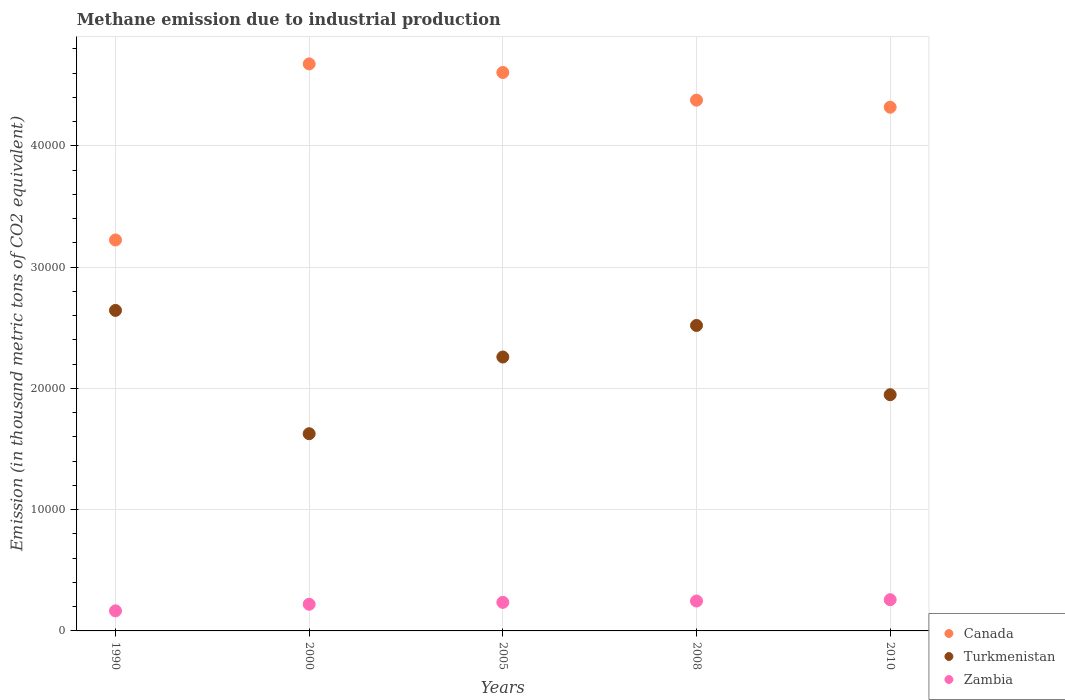Is the number of dotlines equal to the number of legend labels?
Offer a terse response. Yes. What is the amount of methane emitted in Turkmenistan in 2010?
Keep it short and to the point. 1.95e+04. Across all years, what is the maximum amount of methane emitted in Canada?
Your answer should be very brief. 4.68e+04. Across all years, what is the minimum amount of methane emitted in Zambia?
Provide a succinct answer. 1655.8. In which year was the amount of methane emitted in Turkmenistan minimum?
Offer a very short reply. 2000. What is the total amount of methane emitted in Canada in the graph?
Provide a short and direct response. 2.12e+05. What is the difference between the amount of methane emitted in Zambia in 2005 and that in 2010?
Offer a terse response. -219.7. What is the difference between the amount of methane emitted in Canada in 2005 and the amount of methane emitted in Turkmenistan in 2000?
Keep it short and to the point. 2.98e+04. What is the average amount of methane emitted in Canada per year?
Your answer should be compact. 4.24e+04. In the year 2005, what is the difference between the amount of methane emitted in Zambia and amount of methane emitted in Canada?
Offer a very short reply. -4.37e+04. In how many years, is the amount of methane emitted in Turkmenistan greater than 24000 thousand metric tons?
Provide a succinct answer. 2. What is the ratio of the amount of methane emitted in Turkmenistan in 2000 to that in 2010?
Ensure brevity in your answer.  0.83. What is the difference between the highest and the second highest amount of methane emitted in Turkmenistan?
Provide a succinct answer. 1240.2. What is the difference between the highest and the lowest amount of methane emitted in Canada?
Your answer should be compact. 1.45e+04. In how many years, is the amount of methane emitted in Turkmenistan greater than the average amount of methane emitted in Turkmenistan taken over all years?
Ensure brevity in your answer.  3. Is the sum of the amount of methane emitted in Zambia in 1990 and 2008 greater than the maximum amount of methane emitted in Canada across all years?
Ensure brevity in your answer.  No. Is it the case that in every year, the sum of the amount of methane emitted in Zambia and amount of methane emitted in Canada  is greater than the amount of methane emitted in Turkmenistan?
Your answer should be very brief. Yes. Does the amount of methane emitted in Canada monotonically increase over the years?
Make the answer very short. No. How many dotlines are there?
Provide a short and direct response. 3. What is the difference between two consecutive major ticks on the Y-axis?
Ensure brevity in your answer.  10000. Does the graph contain any zero values?
Give a very brief answer. No. Does the graph contain grids?
Provide a succinct answer. Yes. Where does the legend appear in the graph?
Your answer should be very brief. Bottom right. How many legend labels are there?
Your response must be concise. 3. What is the title of the graph?
Offer a terse response. Methane emission due to industrial production. What is the label or title of the X-axis?
Provide a short and direct response. Years. What is the label or title of the Y-axis?
Offer a terse response. Emission (in thousand metric tons of CO2 equivalent). What is the Emission (in thousand metric tons of CO2 equivalent) of Canada in 1990?
Make the answer very short. 3.22e+04. What is the Emission (in thousand metric tons of CO2 equivalent) in Turkmenistan in 1990?
Keep it short and to the point. 2.64e+04. What is the Emission (in thousand metric tons of CO2 equivalent) of Zambia in 1990?
Ensure brevity in your answer.  1655.8. What is the Emission (in thousand metric tons of CO2 equivalent) of Canada in 2000?
Give a very brief answer. 4.68e+04. What is the Emission (in thousand metric tons of CO2 equivalent) in Turkmenistan in 2000?
Ensure brevity in your answer.  1.63e+04. What is the Emission (in thousand metric tons of CO2 equivalent) in Zambia in 2000?
Give a very brief answer. 2197.5. What is the Emission (in thousand metric tons of CO2 equivalent) of Canada in 2005?
Your answer should be compact. 4.60e+04. What is the Emission (in thousand metric tons of CO2 equivalent) of Turkmenistan in 2005?
Provide a short and direct response. 2.26e+04. What is the Emission (in thousand metric tons of CO2 equivalent) of Zambia in 2005?
Offer a terse response. 2355. What is the Emission (in thousand metric tons of CO2 equivalent) of Canada in 2008?
Give a very brief answer. 4.38e+04. What is the Emission (in thousand metric tons of CO2 equivalent) in Turkmenistan in 2008?
Give a very brief answer. 2.52e+04. What is the Emission (in thousand metric tons of CO2 equivalent) in Zambia in 2008?
Your answer should be compact. 2464.9. What is the Emission (in thousand metric tons of CO2 equivalent) of Canada in 2010?
Ensure brevity in your answer.  4.32e+04. What is the Emission (in thousand metric tons of CO2 equivalent) in Turkmenistan in 2010?
Keep it short and to the point. 1.95e+04. What is the Emission (in thousand metric tons of CO2 equivalent) of Zambia in 2010?
Your response must be concise. 2574.7. Across all years, what is the maximum Emission (in thousand metric tons of CO2 equivalent) in Canada?
Ensure brevity in your answer.  4.68e+04. Across all years, what is the maximum Emission (in thousand metric tons of CO2 equivalent) in Turkmenistan?
Provide a short and direct response. 2.64e+04. Across all years, what is the maximum Emission (in thousand metric tons of CO2 equivalent) of Zambia?
Your answer should be very brief. 2574.7. Across all years, what is the minimum Emission (in thousand metric tons of CO2 equivalent) in Canada?
Ensure brevity in your answer.  3.22e+04. Across all years, what is the minimum Emission (in thousand metric tons of CO2 equivalent) of Turkmenistan?
Provide a succinct answer. 1.63e+04. Across all years, what is the minimum Emission (in thousand metric tons of CO2 equivalent) in Zambia?
Provide a succinct answer. 1655.8. What is the total Emission (in thousand metric tons of CO2 equivalent) in Canada in the graph?
Provide a short and direct response. 2.12e+05. What is the total Emission (in thousand metric tons of CO2 equivalent) of Turkmenistan in the graph?
Provide a succinct answer. 1.10e+05. What is the total Emission (in thousand metric tons of CO2 equivalent) in Zambia in the graph?
Provide a short and direct response. 1.12e+04. What is the difference between the Emission (in thousand metric tons of CO2 equivalent) in Canada in 1990 and that in 2000?
Provide a succinct answer. -1.45e+04. What is the difference between the Emission (in thousand metric tons of CO2 equivalent) in Turkmenistan in 1990 and that in 2000?
Provide a short and direct response. 1.02e+04. What is the difference between the Emission (in thousand metric tons of CO2 equivalent) in Zambia in 1990 and that in 2000?
Provide a succinct answer. -541.7. What is the difference between the Emission (in thousand metric tons of CO2 equivalent) of Canada in 1990 and that in 2005?
Provide a succinct answer. -1.38e+04. What is the difference between the Emission (in thousand metric tons of CO2 equivalent) in Turkmenistan in 1990 and that in 2005?
Your answer should be very brief. 3842.2. What is the difference between the Emission (in thousand metric tons of CO2 equivalent) of Zambia in 1990 and that in 2005?
Your answer should be very brief. -699.2. What is the difference between the Emission (in thousand metric tons of CO2 equivalent) of Canada in 1990 and that in 2008?
Keep it short and to the point. -1.15e+04. What is the difference between the Emission (in thousand metric tons of CO2 equivalent) in Turkmenistan in 1990 and that in 2008?
Offer a very short reply. 1240.2. What is the difference between the Emission (in thousand metric tons of CO2 equivalent) of Zambia in 1990 and that in 2008?
Offer a terse response. -809.1. What is the difference between the Emission (in thousand metric tons of CO2 equivalent) in Canada in 1990 and that in 2010?
Your answer should be very brief. -1.09e+04. What is the difference between the Emission (in thousand metric tons of CO2 equivalent) in Turkmenistan in 1990 and that in 2010?
Provide a succinct answer. 6950.9. What is the difference between the Emission (in thousand metric tons of CO2 equivalent) of Zambia in 1990 and that in 2010?
Your answer should be very brief. -918.9. What is the difference between the Emission (in thousand metric tons of CO2 equivalent) of Canada in 2000 and that in 2005?
Make the answer very short. 705.9. What is the difference between the Emission (in thousand metric tons of CO2 equivalent) in Turkmenistan in 2000 and that in 2005?
Your response must be concise. -6325. What is the difference between the Emission (in thousand metric tons of CO2 equivalent) of Zambia in 2000 and that in 2005?
Provide a succinct answer. -157.5. What is the difference between the Emission (in thousand metric tons of CO2 equivalent) in Canada in 2000 and that in 2008?
Your answer should be compact. 2987.1. What is the difference between the Emission (in thousand metric tons of CO2 equivalent) of Turkmenistan in 2000 and that in 2008?
Provide a short and direct response. -8927. What is the difference between the Emission (in thousand metric tons of CO2 equivalent) in Zambia in 2000 and that in 2008?
Your response must be concise. -267.4. What is the difference between the Emission (in thousand metric tons of CO2 equivalent) in Canada in 2000 and that in 2010?
Offer a terse response. 3569.2. What is the difference between the Emission (in thousand metric tons of CO2 equivalent) in Turkmenistan in 2000 and that in 2010?
Keep it short and to the point. -3216.3. What is the difference between the Emission (in thousand metric tons of CO2 equivalent) in Zambia in 2000 and that in 2010?
Provide a short and direct response. -377.2. What is the difference between the Emission (in thousand metric tons of CO2 equivalent) in Canada in 2005 and that in 2008?
Offer a terse response. 2281.2. What is the difference between the Emission (in thousand metric tons of CO2 equivalent) in Turkmenistan in 2005 and that in 2008?
Your response must be concise. -2602. What is the difference between the Emission (in thousand metric tons of CO2 equivalent) of Zambia in 2005 and that in 2008?
Offer a terse response. -109.9. What is the difference between the Emission (in thousand metric tons of CO2 equivalent) of Canada in 2005 and that in 2010?
Your answer should be compact. 2863.3. What is the difference between the Emission (in thousand metric tons of CO2 equivalent) of Turkmenistan in 2005 and that in 2010?
Offer a very short reply. 3108.7. What is the difference between the Emission (in thousand metric tons of CO2 equivalent) in Zambia in 2005 and that in 2010?
Provide a succinct answer. -219.7. What is the difference between the Emission (in thousand metric tons of CO2 equivalent) in Canada in 2008 and that in 2010?
Offer a terse response. 582.1. What is the difference between the Emission (in thousand metric tons of CO2 equivalent) of Turkmenistan in 2008 and that in 2010?
Ensure brevity in your answer.  5710.7. What is the difference between the Emission (in thousand metric tons of CO2 equivalent) in Zambia in 2008 and that in 2010?
Give a very brief answer. -109.8. What is the difference between the Emission (in thousand metric tons of CO2 equivalent) of Canada in 1990 and the Emission (in thousand metric tons of CO2 equivalent) of Turkmenistan in 2000?
Provide a succinct answer. 1.60e+04. What is the difference between the Emission (in thousand metric tons of CO2 equivalent) of Canada in 1990 and the Emission (in thousand metric tons of CO2 equivalent) of Zambia in 2000?
Provide a succinct answer. 3.00e+04. What is the difference between the Emission (in thousand metric tons of CO2 equivalent) of Turkmenistan in 1990 and the Emission (in thousand metric tons of CO2 equivalent) of Zambia in 2000?
Ensure brevity in your answer.  2.42e+04. What is the difference between the Emission (in thousand metric tons of CO2 equivalent) of Canada in 1990 and the Emission (in thousand metric tons of CO2 equivalent) of Turkmenistan in 2005?
Your answer should be compact. 9649.1. What is the difference between the Emission (in thousand metric tons of CO2 equivalent) in Canada in 1990 and the Emission (in thousand metric tons of CO2 equivalent) in Zambia in 2005?
Your answer should be compact. 2.99e+04. What is the difference between the Emission (in thousand metric tons of CO2 equivalent) in Turkmenistan in 1990 and the Emission (in thousand metric tons of CO2 equivalent) in Zambia in 2005?
Your answer should be very brief. 2.41e+04. What is the difference between the Emission (in thousand metric tons of CO2 equivalent) in Canada in 1990 and the Emission (in thousand metric tons of CO2 equivalent) in Turkmenistan in 2008?
Make the answer very short. 7047.1. What is the difference between the Emission (in thousand metric tons of CO2 equivalent) of Canada in 1990 and the Emission (in thousand metric tons of CO2 equivalent) of Zambia in 2008?
Your response must be concise. 2.98e+04. What is the difference between the Emission (in thousand metric tons of CO2 equivalent) in Turkmenistan in 1990 and the Emission (in thousand metric tons of CO2 equivalent) in Zambia in 2008?
Your answer should be very brief. 2.40e+04. What is the difference between the Emission (in thousand metric tons of CO2 equivalent) of Canada in 1990 and the Emission (in thousand metric tons of CO2 equivalent) of Turkmenistan in 2010?
Provide a succinct answer. 1.28e+04. What is the difference between the Emission (in thousand metric tons of CO2 equivalent) of Canada in 1990 and the Emission (in thousand metric tons of CO2 equivalent) of Zambia in 2010?
Offer a very short reply. 2.97e+04. What is the difference between the Emission (in thousand metric tons of CO2 equivalent) in Turkmenistan in 1990 and the Emission (in thousand metric tons of CO2 equivalent) in Zambia in 2010?
Your answer should be compact. 2.39e+04. What is the difference between the Emission (in thousand metric tons of CO2 equivalent) in Canada in 2000 and the Emission (in thousand metric tons of CO2 equivalent) in Turkmenistan in 2005?
Make the answer very short. 2.42e+04. What is the difference between the Emission (in thousand metric tons of CO2 equivalent) of Canada in 2000 and the Emission (in thousand metric tons of CO2 equivalent) of Zambia in 2005?
Keep it short and to the point. 4.44e+04. What is the difference between the Emission (in thousand metric tons of CO2 equivalent) of Turkmenistan in 2000 and the Emission (in thousand metric tons of CO2 equivalent) of Zambia in 2005?
Your answer should be compact. 1.39e+04. What is the difference between the Emission (in thousand metric tons of CO2 equivalent) of Canada in 2000 and the Emission (in thousand metric tons of CO2 equivalent) of Turkmenistan in 2008?
Offer a very short reply. 2.16e+04. What is the difference between the Emission (in thousand metric tons of CO2 equivalent) of Canada in 2000 and the Emission (in thousand metric tons of CO2 equivalent) of Zambia in 2008?
Your response must be concise. 4.43e+04. What is the difference between the Emission (in thousand metric tons of CO2 equivalent) of Turkmenistan in 2000 and the Emission (in thousand metric tons of CO2 equivalent) of Zambia in 2008?
Your answer should be very brief. 1.38e+04. What is the difference between the Emission (in thousand metric tons of CO2 equivalent) in Canada in 2000 and the Emission (in thousand metric tons of CO2 equivalent) in Turkmenistan in 2010?
Provide a short and direct response. 2.73e+04. What is the difference between the Emission (in thousand metric tons of CO2 equivalent) of Canada in 2000 and the Emission (in thousand metric tons of CO2 equivalent) of Zambia in 2010?
Your answer should be compact. 4.42e+04. What is the difference between the Emission (in thousand metric tons of CO2 equivalent) of Turkmenistan in 2000 and the Emission (in thousand metric tons of CO2 equivalent) of Zambia in 2010?
Your response must be concise. 1.37e+04. What is the difference between the Emission (in thousand metric tons of CO2 equivalent) in Canada in 2005 and the Emission (in thousand metric tons of CO2 equivalent) in Turkmenistan in 2008?
Give a very brief answer. 2.09e+04. What is the difference between the Emission (in thousand metric tons of CO2 equivalent) of Canada in 2005 and the Emission (in thousand metric tons of CO2 equivalent) of Zambia in 2008?
Your answer should be very brief. 4.36e+04. What is the difference between the Emission (in thousand metric tons of CO2 equivalent) of Turkmenistan in 2005 and the Emission (in thousand metric tons of CO2 equivalent) of Zambia in 2008?
Your response must be concise. 2.01e+04. What is the difference between the Emission (in thousand metric tons of CO2 equivalent) in Canada in 2005 and the Emission (in thousand metric tons of CO2 equivalent) in Turkmenistan in 2010?
Provide a succinct answer. 2.66e+04. What is the difference between the Emission (in thousand metric tons of CO2 equivalent) of Canada in 2005 and the Emission (in thousand metric tons of CO2 equivalent) of Zambia in 2010?
Provide a succinct answer. 4.35e+04. What is the difference between the Emission (in thousand metric tons of CO2 equivalent) in Turkmenistan in 2005 and the Emission (in thousand metric tons of CO2 equivalent) in Zambia in 2010?
Make the answer very short. 2.00e+04. What is the difference between the Emission (in thousand metric tons of CO2 equivalent) in Canada in 2008 and the Emission (in thousand metric tons of CO2 equivalent) in Turkmenistan in 2010?
Give a very brief answer. 2.43e+04. What is the difference between the Emission (in thousand metric tons of CO2 equivalent) of Canada in 2008 and the Emission (in thousand metric tons of CO2 equivalent) of Zambia in 2010?
Your answer should be very brief. 4.12e+04. What is the difference between the Emission (in thousand metric tons of CO2 equivalent) in Turkmenistan in 2008 and the Emission (in thousand metric tons of CO2 equivalent) in Zambia in 2010?
Make the answer very short. 2.26e+04. What is the average Emission (in thousand metric tons of CO2 equivalent) of Canada per year?
Offer a very short reply. 4.24e+04. What is the average Emission (in thousand metric tons of CO2 equivalent) in Turkmenistan per year?
Your answer should be compact. 2.20e+04. What is the average Emission (in thousand metric tons of CO2 equivalent) of Zambia per year?
Your response must be concise. 2249.58. In the year 1990, what is the difference between the Emission (in thousand metric tons of CO2 equivalent) of Canada and Emission (in thousand metric tons of CO2 equivalent) of Turkmenistan?
Keep it short and to the point. 5806.9. In the year 1990, what is the difference between the Emission (in thousand metric tons of CO2 equivalent) of Canada and Emission (in thousand metric tons of CO2 equivalent) of Zambia?
Ensure brevity in your answer.  3.06e+04. In the year 1990, what is the difference between the Emission (in thousand metric tons of CO2 equivalent) of Turkmenistan and Emission (in thousand metric tons of CO2 equivalent) of Zambia?
Keep it short and to the point. 2.48e+04. In the year 2000, what is the difference between the Emission (in thousand metric tons of CO2 equivalent) of Canada and Emission (in thousand metric tons of CO2 equivalent) of Turkmenistan?
Give a very brief answer. 3.05e+04. In the year 2000, what is the difference between the Emission (in thousand metric tons of CO2 equivalent) in Canada and Emission (in thousand metric tons of CO2 equivalent) in Zambia?
Offer a terse response. 4.46e+04. In the year 2000, what is the difference between the Emission (in thousand metric tons of CO2 equivalent) of Turkmenistan and Emission (in thousand metric tons of CO2 equivalent) of Zambia?
Keep it short and to the point. 1.41e+04. In the year 2005, what is the difference between the Emission (in thousand metric tons of CO2 equivalent) of Canada and Emission (in thousand metric tons of CO2 equivalent) of Turkmenistan?
Your answer should be compact. 2.35e+04. In the year 2005, what is the difference between the Emission (in thousand metric tons of CO2 equivalent) in Canada and Emission (in thousand metric tons of CO2 equivalent) in Zambia?
Your answer should be very brief. 4.37e+04. In the year 2005, what is the difference between the Emission (in thousand metric tons of CO2 equivalent) in Turkmenistan and Emission (in thousand metric tons of CO2 equivalent) in Zambia?
Keep it short and to the point. 2.02e+04. In the year 2008, what is the difference between the Emission (in thousand metric tons of CO2 equivalent) in Canada and Emission (in thousand metric tons of CO2 equivalent) in Turkmenistan?
Provide a short and direct response. 1.86e+04. In the year 2008, what is the difference between the Emission (in thousand metric tons of CO2 equivalent) in Canada and Emission (in thousand metric tons of CO2 equivalent) in Zambia?
Ensure brevity in your answer.  4.13e+04. In the year 2008, what is the difference between the Emission (in thousand metric tons of CO2 equivalent) of Turkmenistan and Emission (in thousand metric tons of CO2 equivalent) of Zambia?
Provide a short and direct response. 2.27e+04. In the year 2010, what is the difference between the Emission (in thousand metric tons of CO2 equivalent) in Canada and Emission (in thousand metric tons of CO2 equivalent) in Turkmenistan?
Make the answer very short. 2.37e+04. In the year 2010, what is the difference between the Emission (in thousand metric tons of CO2 equivalent) in Canada and Emission (in thousand metric tons of CO2 equivalent) in Zambia?
Give a very brief answer. 4.06e+04. In the year 2010, what is the difference between the Emission (in thousand metric tons of CO2 equivalent) of Turkmenistan and Emission (in thousand metric tons of CO2 equivalent) of Zambia?
Provide a short and direct response. 1.69e+04. What is the ratio of the Emission (in thousand metric tons of CO2 equivalent) of Canada in 1990 to that in 2000?
Keep it short and to the point. 0.69. What is the ratio of the Emission (in thousand metric tons of CO2 equivalent) of Turkmenistan in 1990 to that in 2000?
Make the answer very short. 1.63. What is the ratio of the Emission (in thousand metric tons of CO2 equivalent) of Zambia in 1990 to that in 2000?
Give a very brief answer. 0.75. What is the ratio of the Emission (in thousand metric tons of CO2 equivalent) of Canada in 1990 to that in 2005?
Make the answer very short. 0.7. What is the ratio of the Emission (in thousand metric tons of CO2 equivalent) of Turkmenistan in 1990 to that in 2005?
Give a very brief answer. 1.17. What is the ratio of the Emission (in thousand metric tons of CO2 equivalent) of Zambia in 1990 to that in 2005?
Give a very brief answer. 0.7. What is the ratio of the Emission (in thousand metric tons of CO2 equivalent) in Canada in 1990 to that in 2008?
Your answer should be compact. 0.74. What is the ratio of the Emission (in thousand metric tons of CO2 equivalent) in Turkmenistan in 1990 to that in 2008?
Your answer should be very brief. 1.05. What is the ratio of the Emission (in thousand metric tons of CO2 equivalent) of Zambia in 1990 to that in 2008?
Provide a short and direct response. 0.67. What is the ratio of the Emission (in thousand metric tons of CO2 equivalent) of Canada in 1990 to that in 2010?
Make the answer very short. 0.75. What is the ratio of the Emission (in thousand metric tons of CO2 equivalent) in Turkmenistan in 1990 to that in 2010?
Your answer should be compact. 1.36. What is the ratio of the Emission (in thousand metric tons of CO2 equivalent) of Zambia in 1990 to that in 2010?
Keep it short and to the point. 0.64. What is the ratio of the Emission (in thousand metric tons of CO2 equivalent) of Canada in 2000 to that in 2005?
Your response must be concise. 1.02. What is the ratio of the Emission (in thousand metric tons of CO2 equivalent) in Turkmenistan in 2000 to that in 2005?
Provide a short and direct response. 0.72. What is the ratio of the Emission (in thousand metric tons of CO2 equivalent) of Zambia in 2000 to that in 2005?
Your answer should be very brief. 0.93. What is the ratio of the Emission (in thousand metric tons of CO2 equivalent) in Canada in 2000 to that in 2008?
Your response must be concise. 1.07. What is the ratio of the Emission (in thousand metric tons of CO2 equivalent) in Turkmenistan in 2000 to that in 2008?
Ensure brevity in your answer.  0.65. What is the ratio of the Emission (in thousand metric tons of CO2 equivalent) of Zambia in 2000 to that in 2008?
Provide a short and direct response. 0.89. What is the ratio of the Emission (in thousand metric tons of CO2 equivalent) of Canada in 2000 to that in 2010?
Your answer should be compact. 1.08. What is the ratio of the Emission (in thousand metric tons of CO2 equivalent) of Turkmenistan in 2000 to that in 2010?
Your response must be concise. 0.83. What is the ratio of the Emission (in thousand metric tons of CO2 equivalent) in Zambia in 2000 to that in 2010?
Your answer should be compact. 0.85. What is the ratio of the Emission (in thousand metric tons of CO2 equivalent) of Canada in 2005 to that in 2008?
Provide a succinct answer. 1.05. What is the ratio of the Emission (in thousand metric tons of CO2 equivalent) in Turkmenistan in 2005 to that in 2008?
Your answer should be compact. 0.9. What is the ratio of the Emission (in thousand metric tons of CO2 equivalent) of Zambia in 2005 to that in 2008?
Your response must be concise. 0.96. What is the ratio of the Emission (in thousand metric tons of CO2 equivalent) of Canada in 2005 to that in 2010?
Provide a short and direct response. 1.07. What is the ratio of the Emission (in thousand metric tons of CO2 equivalent) of Turkmenistan in 2005 to that in 2010?
Offer a terse response. 1.16. What is the ratio of the Emission (in thousand metric tons of CO2 equivalent) of Zambia in 2005 to that in 2010?
Ensure brevity in your answer.  0.91. What is the ratio of the Emission (in thousand metric tons of CO2 equivalent) in Canada in 2008 to that in 2010?
Make the answer very short. 1.01. What is the ratio of the Emission (in thousand metric tons of CO2 equivalent) in Turkmenistan in 2008 to that in 2010?
Your response must be concise. 1.29. What is the ratio of the Emission (in thousand metric tons of CO2 equivalent) in Zambia in 2008 to that in 2010?
Ensure brevity in your answer.  0.96. What is the difference between the highest and the second highest Emission (in thousand metric tons of CO2 equivalent) of Canada?
Your response must be concise. 705.9. What is the difference between the highest and the second highest Emission (in thousand metric tons of CO2 equivalent) in Turkmenistan?
Keep it short and to the point. 1240.2. What is the difference between the highest and the second highest Emission (in thousand metric tons of CO2 equivalent) in Zambia?
Your answer should be compact. 109.8. What is the difference between the highest and the lowest Emission (in thousand metric tons of CO2 equivalent) in Canada?
Ensure brevity in your answer.  1.45e+04. What is the difference between the highest and the lowest Emission (in thousand metric tons of CO2 equivalent) in Turkmenistan?
Offer a terse response. 1.02e+04. What is the difference between the highest and the lowest Emission (in thousand metric tons of CO2 equivalent) of Zambia?
Provide a short and direct response. 918.9. 